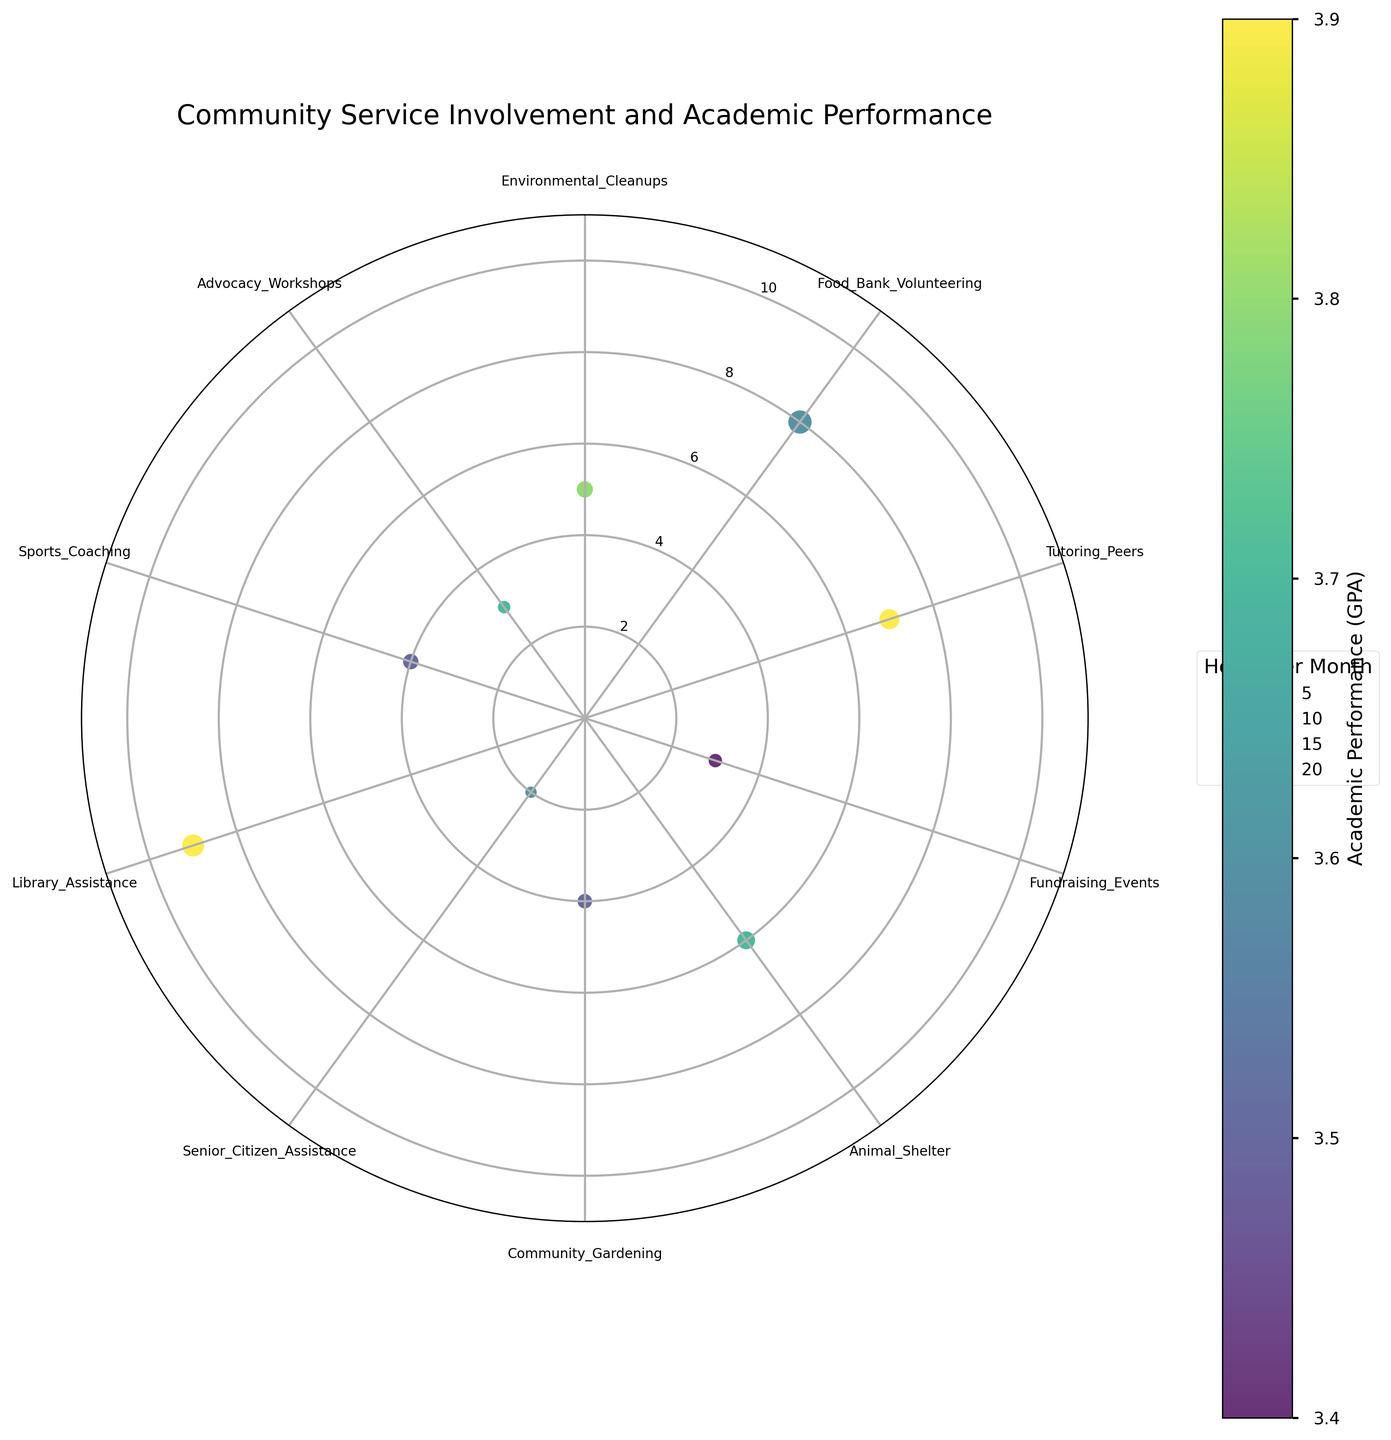What is the title of the chart? The title is written at the top of the chart and summarizes the main theme.
Answer: Community Service Involvement and Academic Performance How many different types of community service are represented in the chart? The number of unique community service types can be determined by counting the labeled ticks on the chart.
Answer: 10 Which community service type has the highest frequency of involvement? Identify the data point farthest from the center along with its corresponding label.
Answer: Library Assistance What is the academic performance (GPA) for Environmental Cleanups? Look at the color coding for Environmental Cleanups to determine its GPA, referenced by the color bar.
Answer: 3.8 Which community service type has the lowest frequency of involvement? Find the data point closest to the center and note its corresponding label.
Answer: Senior Citizen Assistance What is the average frequency of involvement across all community service types? Add the frequencies of involvement for all points and divide by the number of types.
Answer: (5 + 8 + 7 + 3 + 6 + 4 + 2 + 9 + 4 + 3) / 10 = 5.1 How does the frequency of involvement in Food Bank Volunteering compare to that in Fundraising Events? Compare the radii of the points for these community services.
Answer: Food Bank Volunteering has a higher frequency than Fundraising Events Which type of community service has the highest academic performance (GPA) and what is that GPA? Identify the data point with the darkest color, according to the color bar, and note its label and GPA.
Answer: Tutoring Peers and Library Assistance, 3.9 What is the total number of hours per month spent on Sports Coaching and Community Gardening combined? Sum the sizes (hours per month) of the data points for these community services.
Answer: 9 + 8 = 17 Which community service type has the smallest bubble size, and how many hours per month does it represent? Find the smallest bubble and note its label; match the size to the legend for hours per month.
Answer: Senior Citizen Assistance, 5 